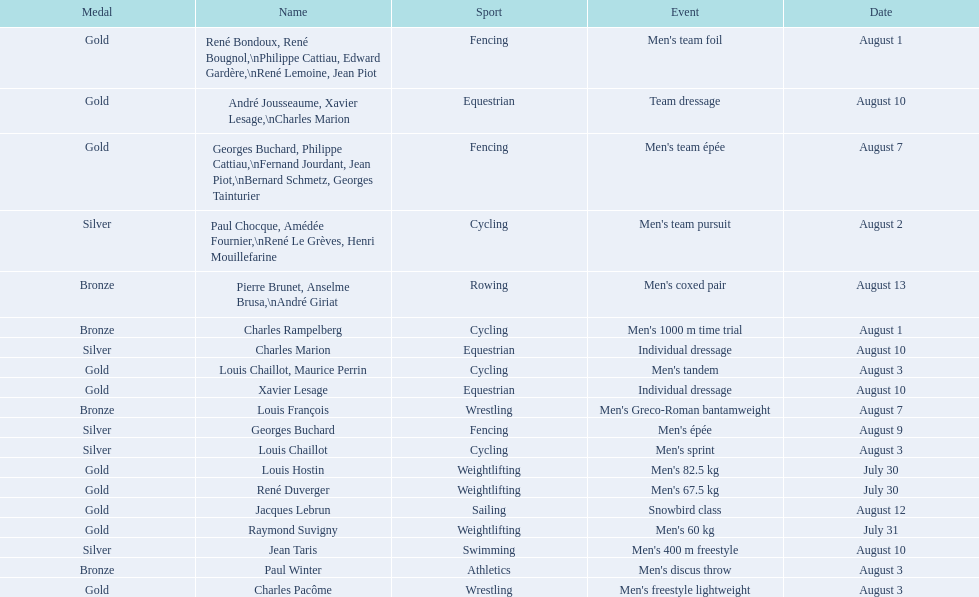Which event won the most medals? Cycling. 